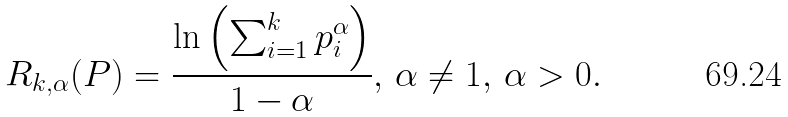Convert formula to latex. <formula><loc_0><loc_0><loc_500><loc_500>R _ { k , \alpha } ( P ) = \frac { \ln \left ( \sum _ { i = 1 } ^ { k } p _ { i } ^ { \alpha } \right ) } { 1 - \alpha } , \, \alpha \neq 1 , \, \alpha > 0 .</formula> 